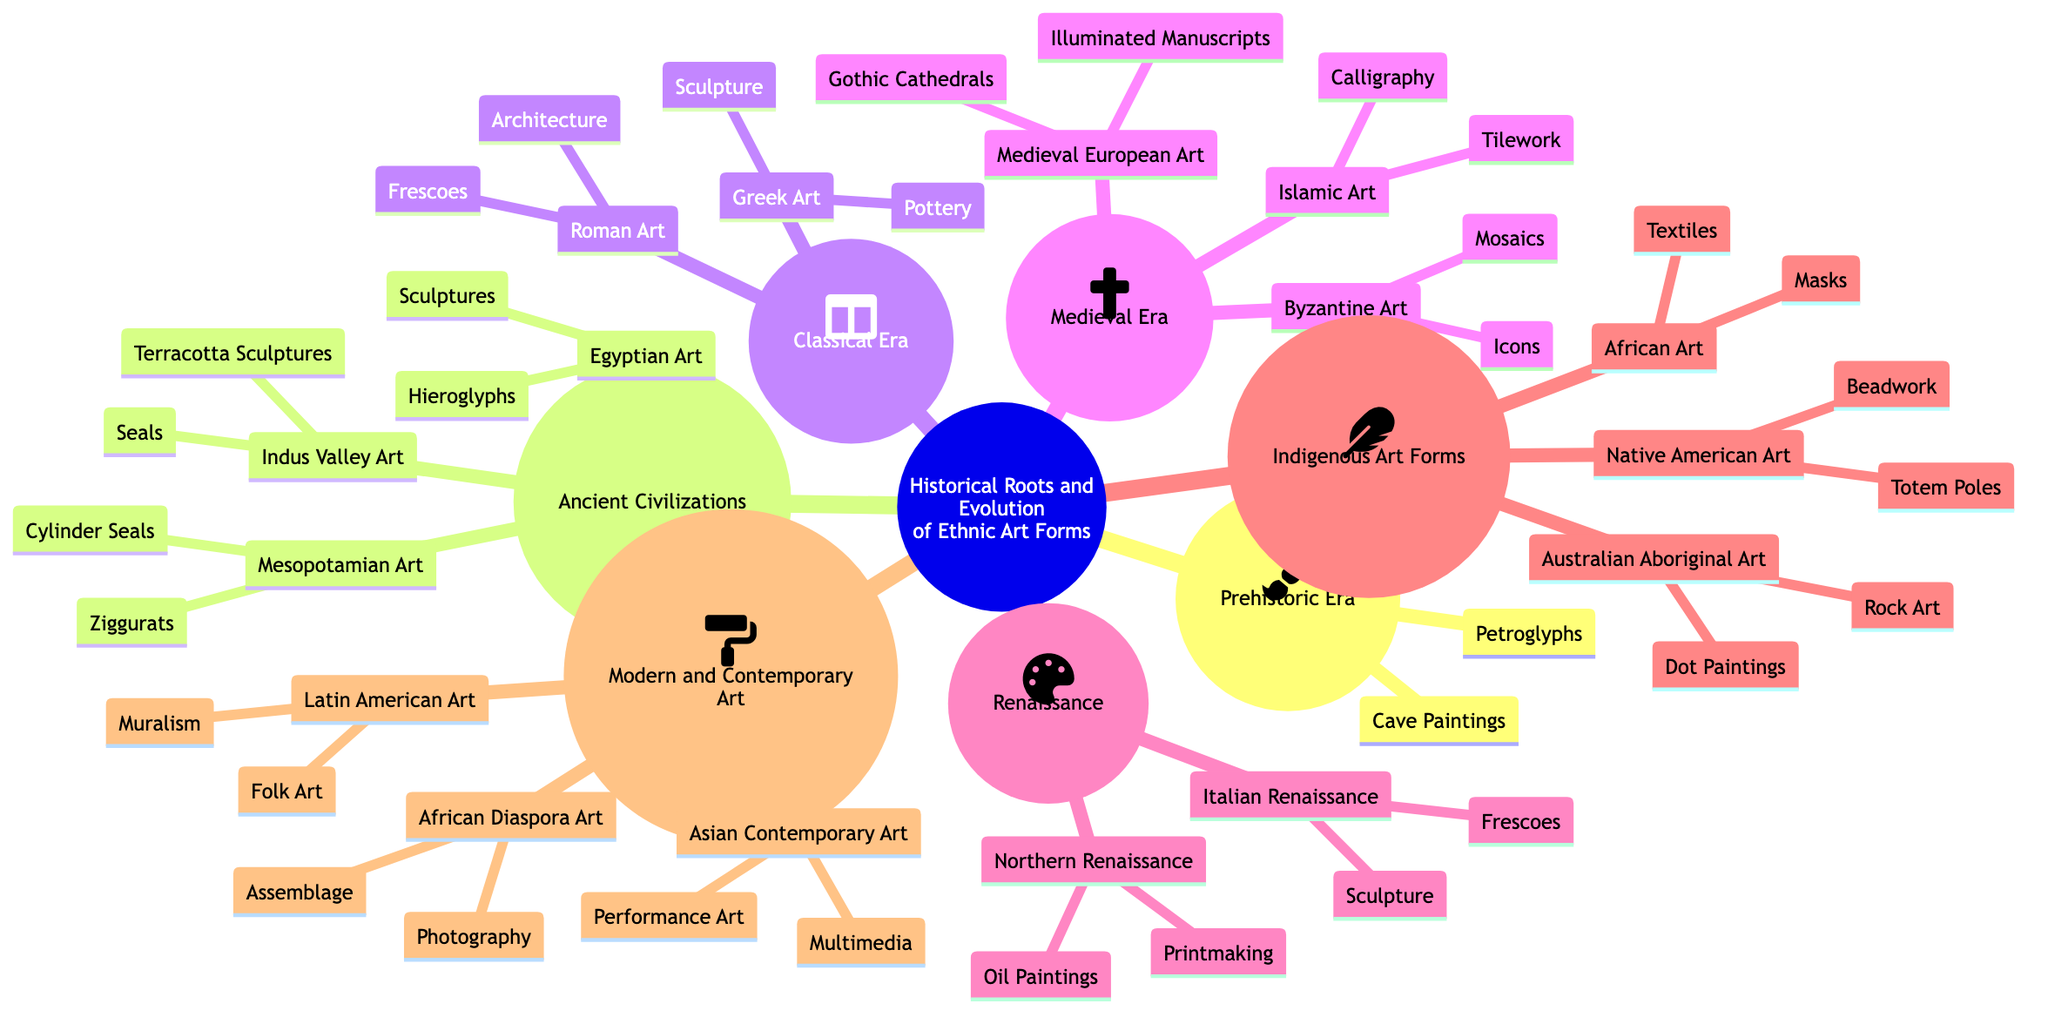What elements are associated with Egyptian Art? The concepts map indicates that the elements associated with Egyptian Art are Hieroglyphs and Sculptures, which are listed directly under the Egyptian Art node.
Answer: Hieroglyphs, Sculptures How many cultures are represented in the Medieval Era? In the diagram, under the Medieval Era node, there are three cultures mentioned: Byzantine Art, Islamic Art, and Medieval European Art.
Answer: 3 Which art form includes elements of Calligraphy? The diagram shows that Islamic Art, under the Medieval Era, includes Calligraphy as one of its elements.
Answer: Islamic Art What influences are associated with Australian Aboriginal Art? Looking at the Indigenous Art Forms section, Australian Aboriginal Art is influenced by Dreamtime Stories and Land, which are listed under its respective node.
Answer: Dreamtime Stories, Land How does Magisterial influence differ between Classical and Medieval eras? The Classical Era, specifically Greek and Roman Art, is influenced by Mythology, Philosophy, Politics, and Engineering while the Medieval Era is influenced by Religion, Science, and Feudal Society. The difference is based on broader themes that link arts to their societal contexts.
Answer: Different influences What element of Latin American Art suggests its socio-political roots? Within the Modern and Contemporary Art section, Latin American Art includes Muralism as an element, which is directly related to its influences of Political Statements and Cultural Identity.
Answer: Muralism How many types of art are documented in the Indigenous Art Forms? The Indigenous Art Forms node lists three cultures: African Art, Native American Art, and Australian Aboriginal Art—indicating three distinct art forms represented.
Answer: 3 Which era is characterized by the revival of classical art forms? The diagram clearly outlines the Renaissance era, labeled as the revival of classical art forms, distinctive from other eras that evolved differently.
Answer: Renaissance What is a common characteristic of art in the Ancient Civilizations? The Ancient Civilizations node appears to have art characterized by strong connections to Religion and Social Structures, influencing multiple cultures’ artistic expressions, especially Egyptian and Mesopotamian.
Answer: Religion, Kingship 